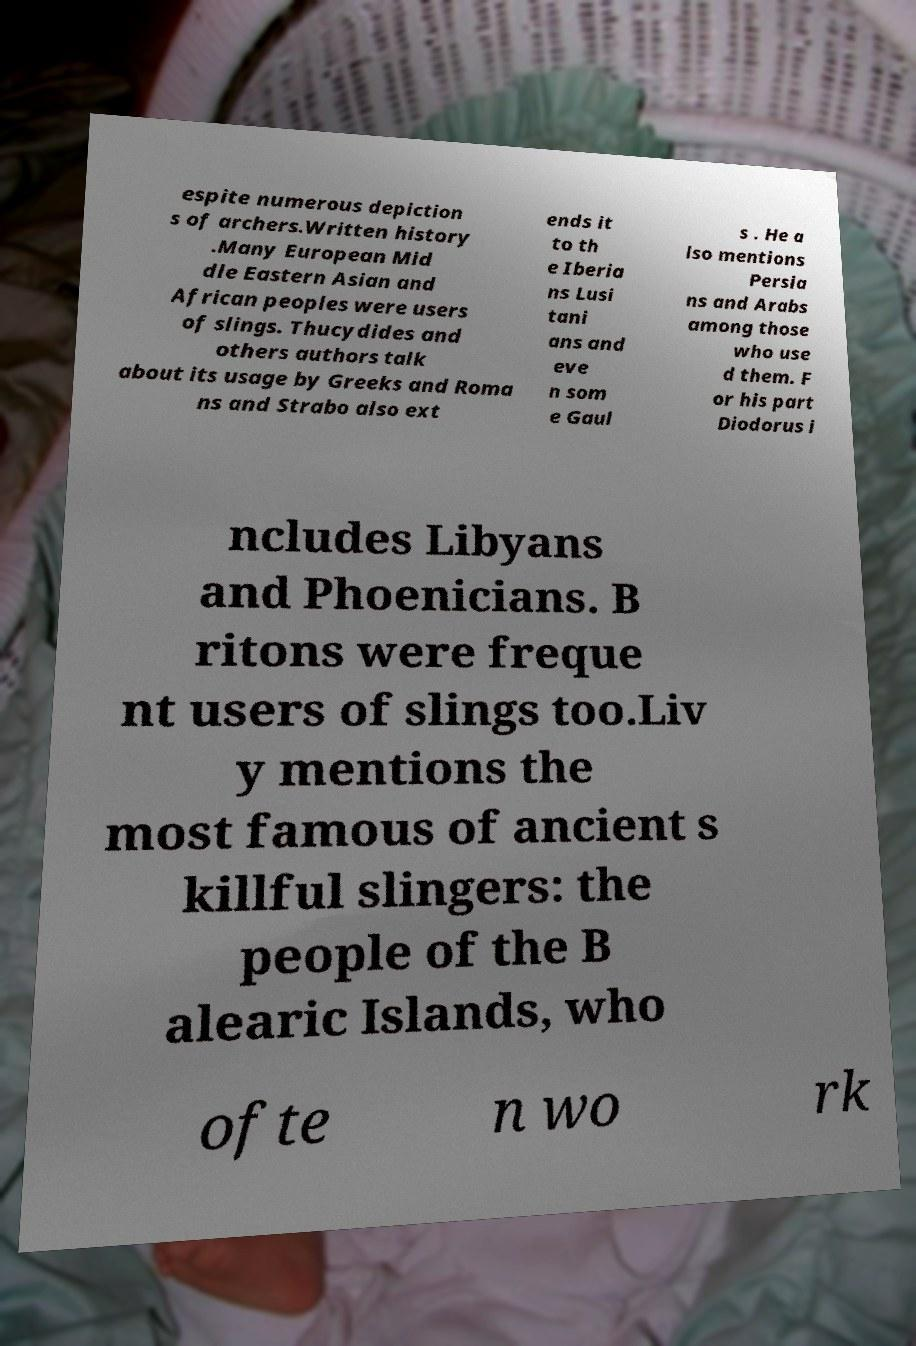What messages or text are displayed in this image? I need them in a readable, typed format. espite numerous depiction s of archers.Written history .Many European Mid dle Eastern Asian and African peoples were users of slings. Thucydides and others authors talk about its usage by Greeks and Roma ns and Strabo also ext ends it to th e Iberia ns Lusi tani ans and eve n som e Gaul s . He a lso mentions Persia ns and Arabs among those who use d them. F or his part Diodorus i ncludes Libyans and Phoenicians. B ritons were freque nt users of slings too.Liv y mentions the most famous of ancient s killful slingers: the people of the B alearic Islands, who ofte n wo rk 